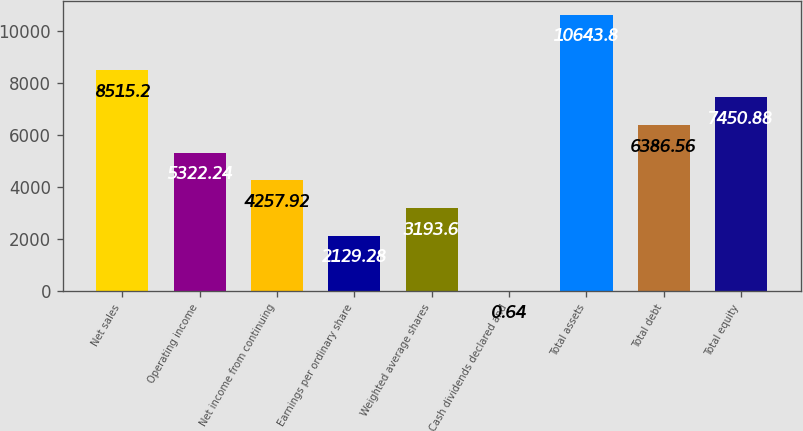Convert chart. <chart><loc_0><loc_0><loc_500><loc_500><bar_chart><fcel>Net sales<fcel>Operating income<fcel>Net income from continuing<fcel>Earnings per ordinary share<fcel>Weighted average shares<fcel>Cash dividends declared and<fcel>Total assets<fcel>Total debt<fcel>Total equity<nl><fcel>8515.2<fcel>5322.24<fcel>4257.92<fcel>2129.28<fcel>3193.6<fcel>0.64<fcel>10643.8<fcel>6386.56<fcel>7450.88<nl></chart> 